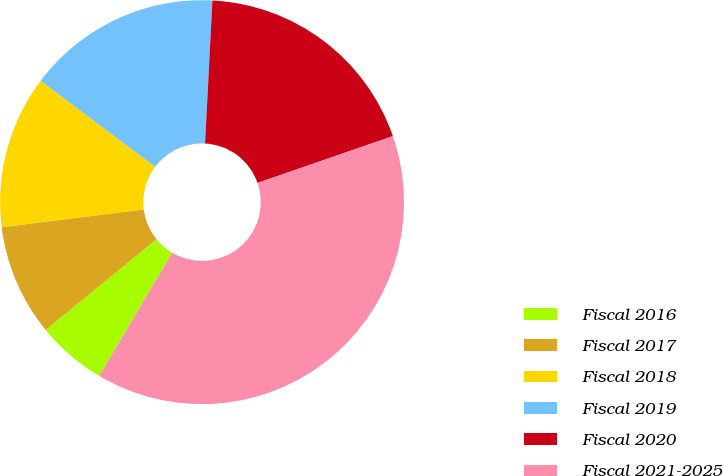Convert chart to OTSL. <chart><loc_0><loc_0><loc_500><loc_500><pie_chart><fcel>Fiscal 2016<fcel>Fiscal 2017<fcel>Fiscal 2018<fcel>Fiscal 2019<fcel>Fiscal 2020<fcel>Fiscal 2021-2025<nl><fcel>5.6%<fcel>8.92%<fcel>12.24%<fcel>15.56%<fcel>18.88%<fcel>38.8%<nl></chart> 